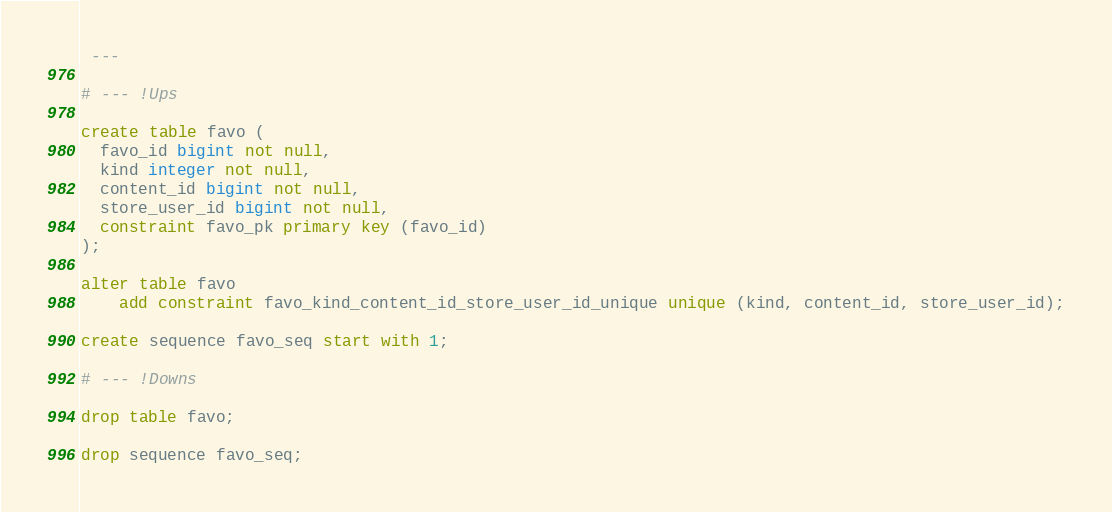<code> <loc_0><loc_0><loc_500><loc_500><_SQL_> ---

# --- !Ups

create table favo ( 
  favo_id bigint not null,
  kind integer not null,
  content_id bigint not null,
  store_user_id bigint not null,
  constraint favo_pk primary key (favo_id)
);

alter table favo
    add constraint favo_kind_content_id_store_user_id_unique unique (kind, content_id, store_user_id);

create sequence favo_seq start with 1;

# --- !Downs

drop table favo;

drop sequence favo_seq;
</code> 